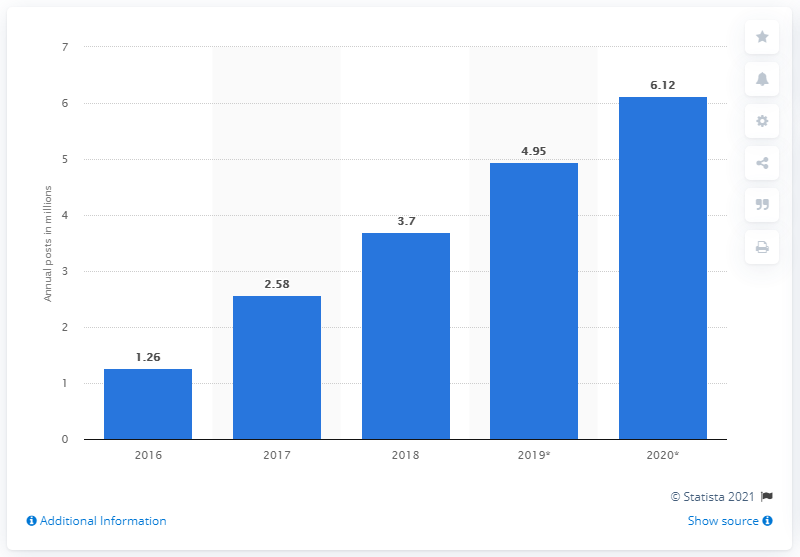Draw attention to some important aspects in this diagram. There were 3.7 brand sponsored influencer posts on Instagram in 2018. The amount of sponsored content on Instagram is expected to be 4.95 in 2019. 